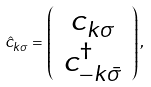Convert formula to latex. <formula><loc_0><loc_0><loc_500><loc_500>\hat { c } _ { k \sigma } = \left ( \begin{array} { c c } c _ { k \sigma } \\ c ^ { \dag } _ { - k \bar { \sigma } } \end{array} \right ) ,</formula> 